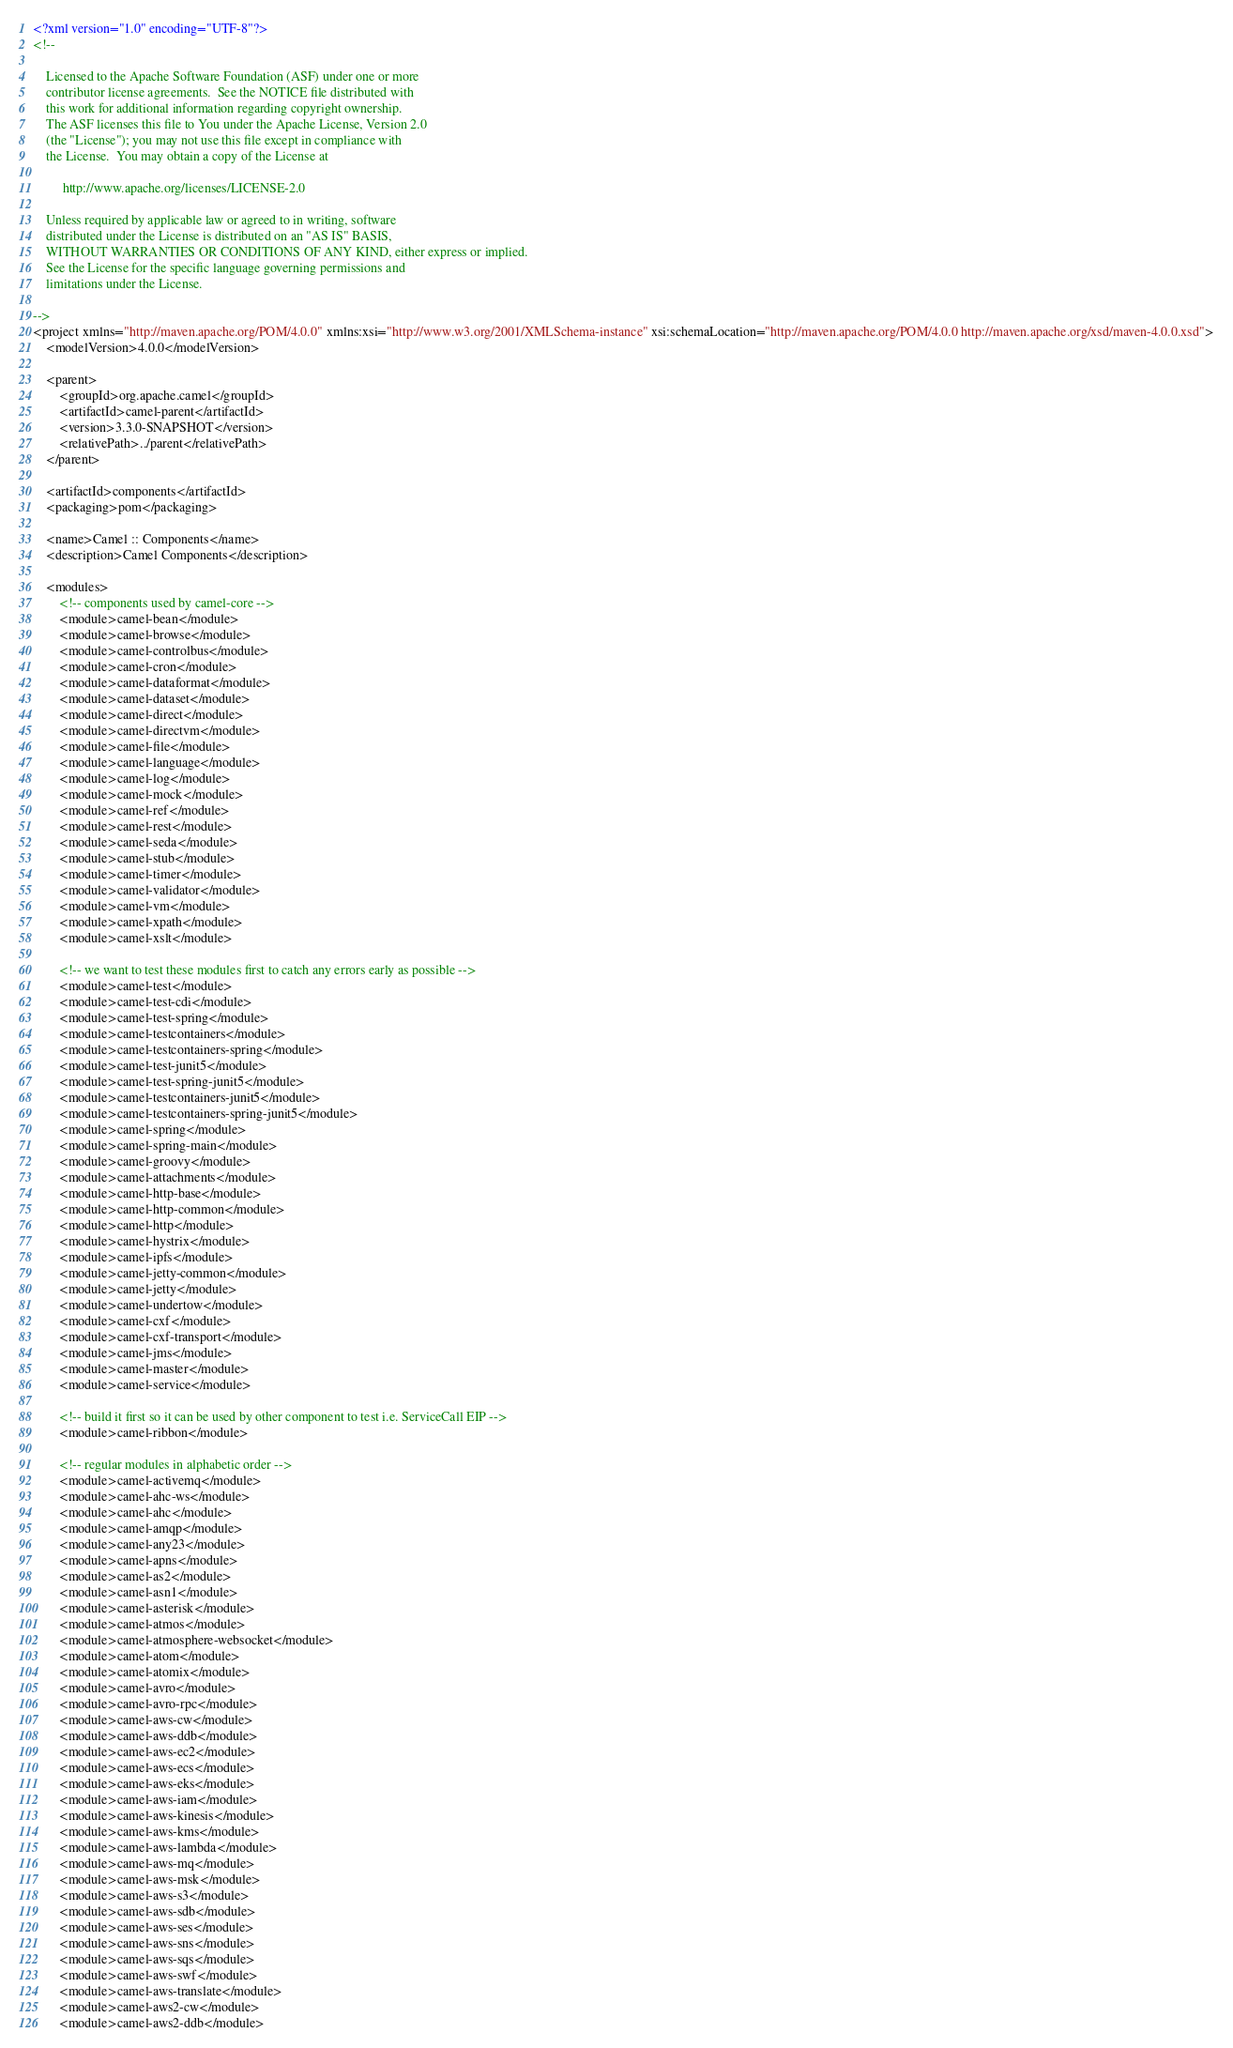<code> <loc_0><loc_0><loc_500><loc_500><_XML_><?xml version="1.0" encoding="UTF-8"?>
<!--

    Licensed to the Apache Software Foundation (ASF) under one or more
    contributor license agreements.  See the NOTICE file distributed with
    this work for additional information regarding copyright ownership.
    The ASF licenses this file to You under the Apache License, Version 2.0
    (the "License"); you may not use this file except in compliance with
    the License.  You may obtain a copy of the License at

         http://www.apache.org/licenses/LICENSE-2.0

    Unless required by applicable law or agreed to in writing, software
    distributed under the License is distributed on an "AS IS" BASIS,
    WITHOUT WARRANTIES OR CONDITIONS OF ANY KIND, either express or implied.
    See the License for the specific language governing permissions and
    limitations under the License.

-->
<project xmlns="http://maven.apache.org/POM/4.0.0" xmlns:xsi="http://www.w3.org/2001/XMLSchema-instance" xsi:schemaLocation="http://maven.apache.org/POM/4.0.0 http://maven.apache.org/xsd/maven-4.0.0.xsd">
    <modelVersion>4.0.0</modelVersion>

    <parent>
        <groupId>org.apache.camel</groupId>
        <artifactId>camel-parent</artifactId>
        <version>3.3.0-SNAPSHOT</version>
        <relativePath>../parent</relativePath>
    </parent>

    <artifactId>components</artifactId>
    <packaging>pom</packaging>

    <name>Camel :: Components</name>
    <description>Camel Components</description>

    <modules>
        <!-- components used by camel-core -->
        <module>camel-bean</module>
        <module>camel-browse</module>
        <module>camel-controlbus</module>
        <module>camel-cron</module>
        <module>camel-dataformat</module>
        <module>camel-dataset</module>
        <module>camel-direct</module>
        <module>camel-directvm</module>
        <module>camel-file</module>
        <module>camel-language</module>
        <module>camel-log</module>
        <module>camel-mock</module>
        <module>camel-ref</module>
        <module>camel-rest</module>
        <module>camel-seda</module>
        <module>camel-stub</module>
        <module>camel-timer</module>
        <module>camel-validator</module>
        <module>camel-vm</module>
        <module>camel-xpath</module>
        <module>camel-xslt</module>

        <!-- we want to test these modules first to catch any errors early as possible -->
        <module>camel-test</module>
        <module>camel-test-cdi</module>
        <module>camel-test-spring</module>
        <module>camel-testcontainers</module>
        <module>camel-testcontainers-spring</module>
        <module>camel-test-junit5</module>
        <module>camel-test-spring-junit5</module>
        <module>camel-testcontainers-junit5</module>
        <module>camel-testcontainers-spring-junit5</module>
        <module>camel-spring</module>
        <module>camel-spring-main</module>
        <module>camel-groovy</module>
        <module>camel-attachments</module>
        <module>camel-http-base</module>
        <module>camel-http-common</module>
        <module>camel-http</module>
        <module>camel-hystrix</module>
        <module>camel-ipfs</module>
        <module>camel-jetty-common</module>
        <module>camel-jetty</module>
        <module>camel-undertow</module>
        <module>camel-cxf</module>
        <module>camel-cxf-transport</module>
        <module>camel-jms</module>
        <module>camel-master</module>
        <module>camel-service</module>

        <!-- build it first so it can be used by other component to test i.e. ServiceCall EIP -->
        <module>camel-ribbon</module>

        <!-- regular modules in alphabetic order -->
        <module>camel-activemq</module>
        <module>camel-ahc-ws</module>
        <module>camel-ahc</module>
        <module>camel-amqp</module>
        <module>camel-any23</module>
        <module>camel-apns</module>
        <module>camel-as2</module>
        <module>camel-asn1</module>
        <module>camel-asterisk</module>
        <module>camel-atmos</module>
        <module>camel-atmosphere-websocket</module>
        <module>camel-atom</module>
        <module>camel-atomix</module>
        <module>camel-avro</module>
        <module>camel-avro-rpc</module>
        <module>camel-aws-cw</module>
        <module>camel-aws-ddb</module>
        <module>camel-aws-ec2</module>
        <module>camel-aws-ecs</module>
        <module>camel-aws-eks</module>
        <module>camel-aws-iam</module>
        <module>camel-aws-kinesis</module>
        <module>camel-aws-kms</module>
        <module>camel-aws-lambda</module>
        <module>camel-aws-mq</module>
        <module>camel-aws-msk</module>
        <module>camel-aws-s3</module>
        <module>camel-aws-sdb</module>
        <module>camel-aws-ses</module>
        <module>camel-aws-sns</module>
        <module>camel-aws-sqs</module>
        <module>camel-aws-swf</module>
        <module>camel-aws-translate</module>
        <module>camel-aws2-cw</module>
        <module>camel-aws2-ddb</module></code> 